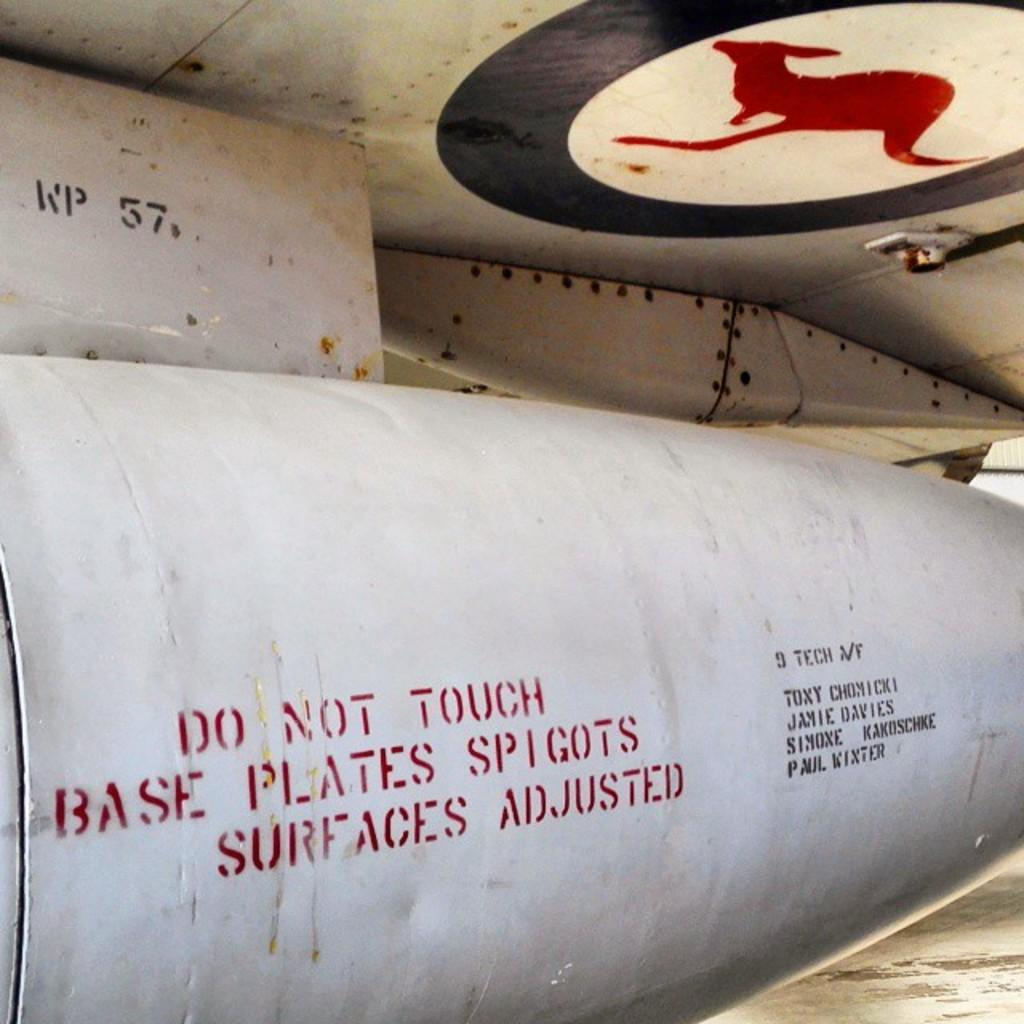<image>
Create a compact narrative representing the image presented. A cement pipe with Do Not Touch written on the side of it. 